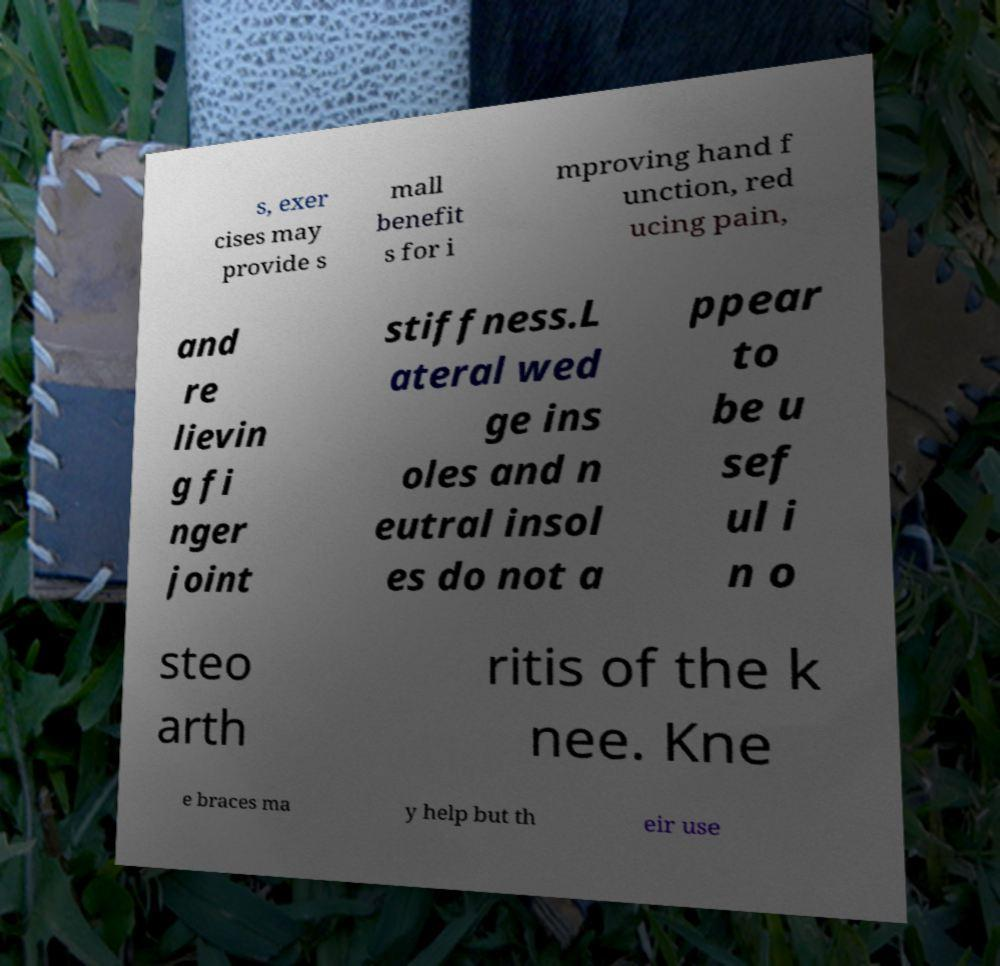Could you assist in decoding the text presented in this image and type it out clearly? s, exer cises may provide s mall benefit s for i mproving hand f unction, red ucing pain, and re lievin g fi nger joint stiffness.L ateral wed ge ins oles and n eutral insol es do not a ppear to be u sef ul i n o steo arth ritis of the k nee. Kne e braces ma y help but th eir use 